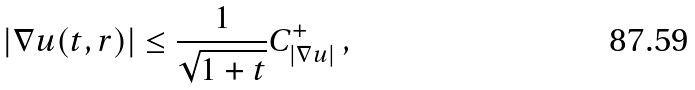<formula> <loc_0><loc_0><loc_500><loc_500>\left | \nabla u ( t , r ) \right | \leq \frac { 1 } { \sqrt { 1 + t } } C ^ { + } _ { | \nabla u | } \ ,</formula> 